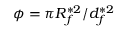Convert formula to latex. <formula><loc_0><loc_0><loc_500><loc_500>\phi = \pi R _ { f } ^ { \ast 2 } / d _ { f } ^ { \ast 2 }</formula> 